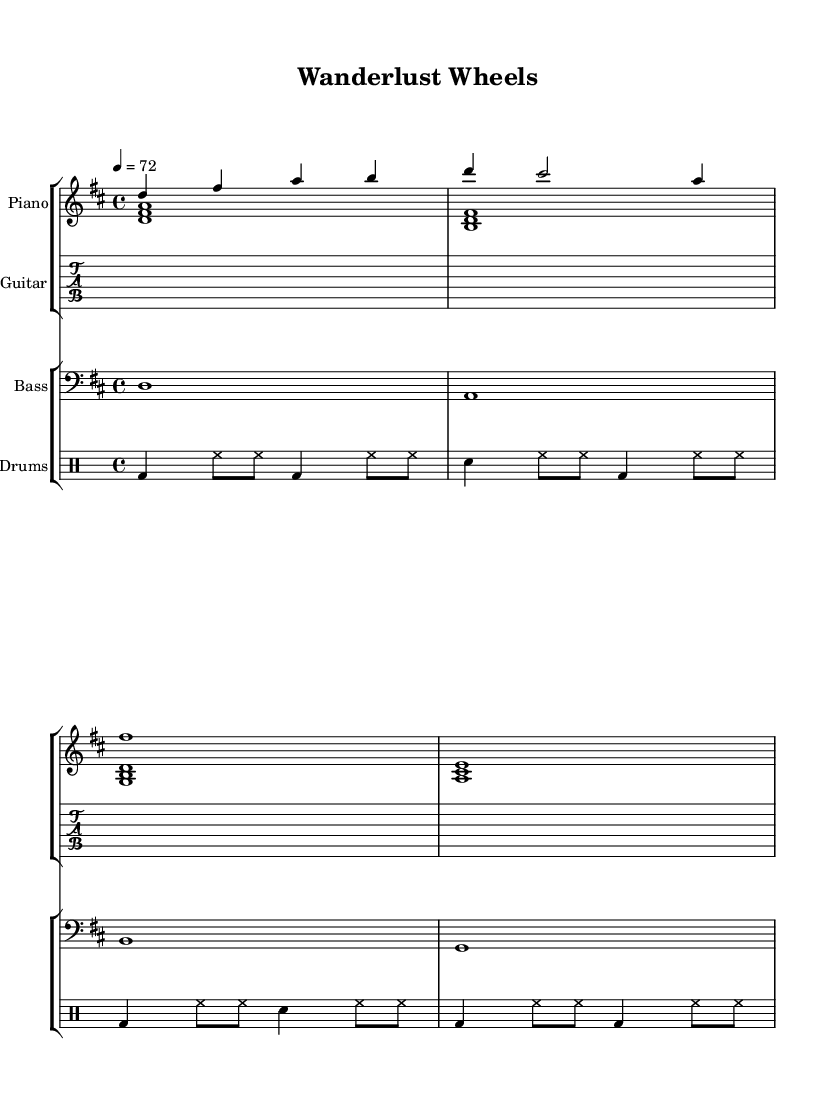What is the key signature of this music? The key signature is indicated at the beginning of the staff, showing two sharps, which represents the key of D major.
Answer: D major What is the time signature of this music? The time signature is found at the beginning of the score, indicated by the "4/4" notation, meaning there are four beats in each measure and the quarter note gets one beat.
Answer: 4/4 What is the tempo marking for this piece? The tempo marking, which indicates the speed of the music, is shown as “4 = 72”, specifying that there are 72 beats per minute.
Answer: 72 How many measures are in the piano part? To determine the number of measures in the piano part, I can count the vertical lines separating the different measures. In the given passage, there are 4 measures shown.
Answer: 4 What instruments are featured in this piece? The score notation includes staves for piano, guitar, bass, and drums, indicating that these are the featured instruments in the piece.
Answer: Piano, guitar, bass, drums What type of rhythm is used for the drums? By analyzing the drummode section, it indicates varying patterns of bass drum and snare hits combined with hi-hat rhythms, typical of jazz styles emphasizing syncopation and swing feel.
Answer: Swing 